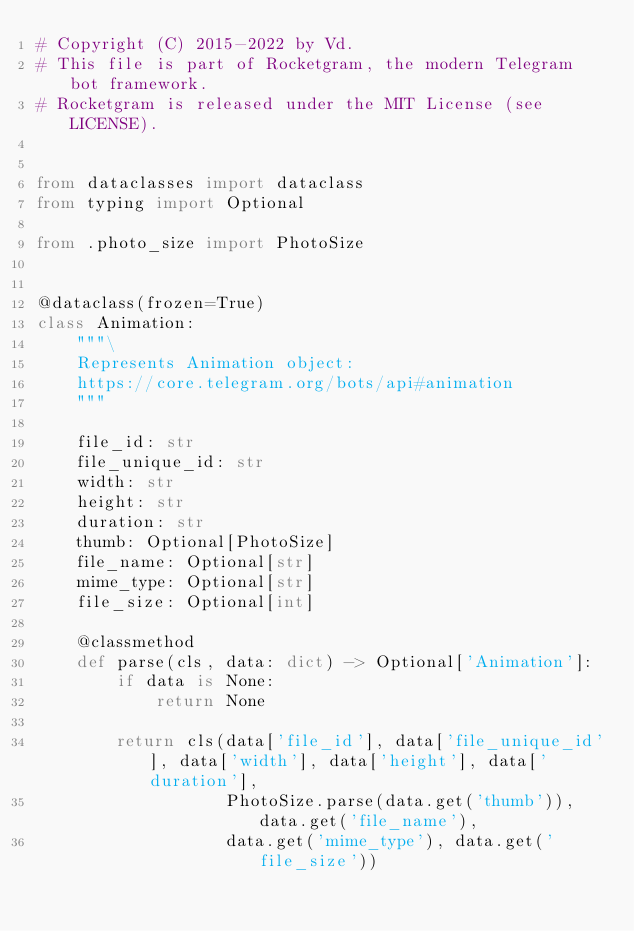<code> <loc_0><loc_0><loc_500><loc_500><_Python_># Copyright (C) 2015-2022 by Vd.
# This file is part of Rocketgram, the modern Telegram bot framework.
# Rocketgram is released under the MIT License (see LICENSE).


from dataclasses import dataclass
from typing import Optional

from .photo_size import PhotoSize


@dataclass(frozen=True)
class Animation:
    """\
    Represents Animation object:
    https://core.telegram.org/bots/api#animation
    """

    file_id: str
    file_unique_id: str
    width: str
    height: str
    duration: str
    thumb: Optional[PhotoSize]
    file_name: Optional[str]
    mime_type: Optional[str]
    file_size: Optional[int]

    @classmethod
    def parse(cls, data: dict) -> Optional['Animation']:
        if data is None:
            return None

        return cls(data['file_id'], data['file_unique_id'], data['width'], data['height'], data['duration'],
                   PhotoSize.parse(data.get('thumb')), data.get('file_name'),
                   data.get('mime_type'), data.get('file_size'))
</code> 